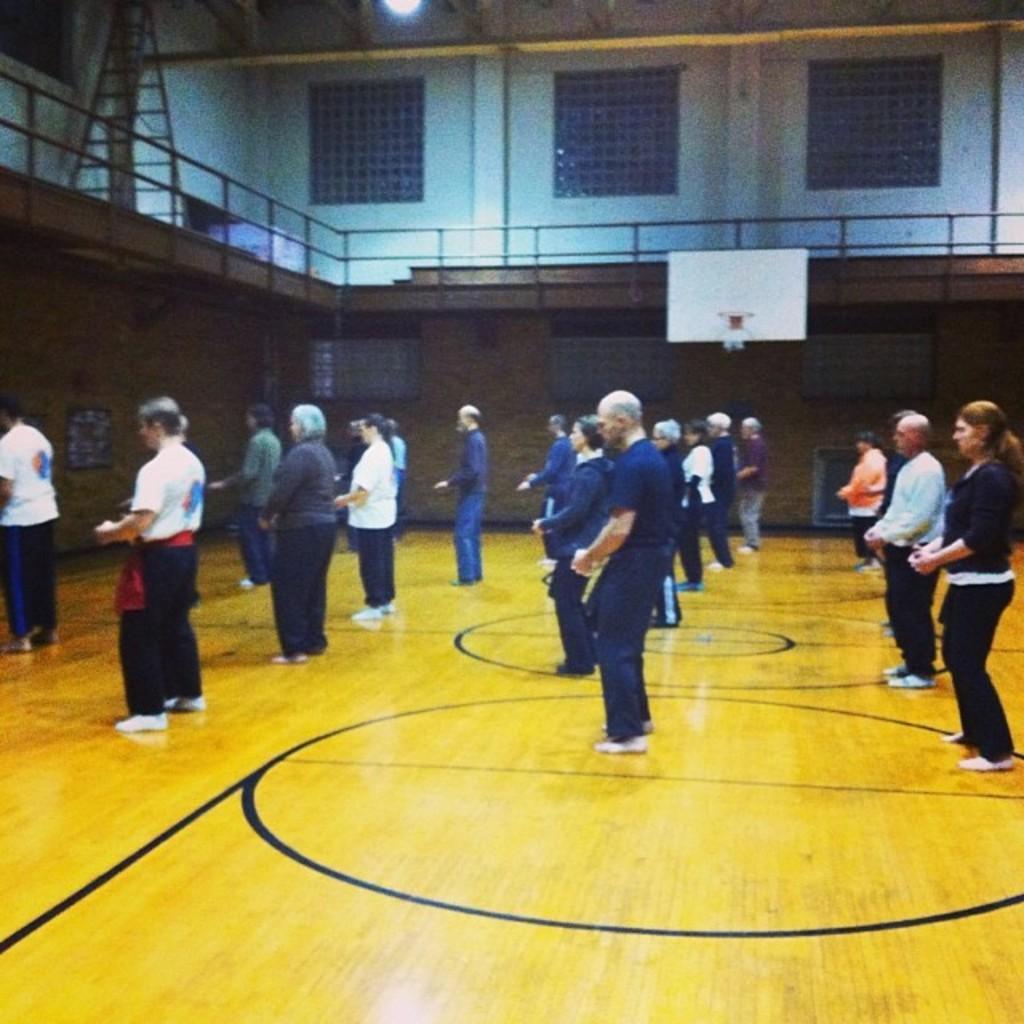Could you give a brief overview of what you see in this image? In this picture there are people standing on the floor. In the background of the image we can see railing, wall, board, windows and light. 